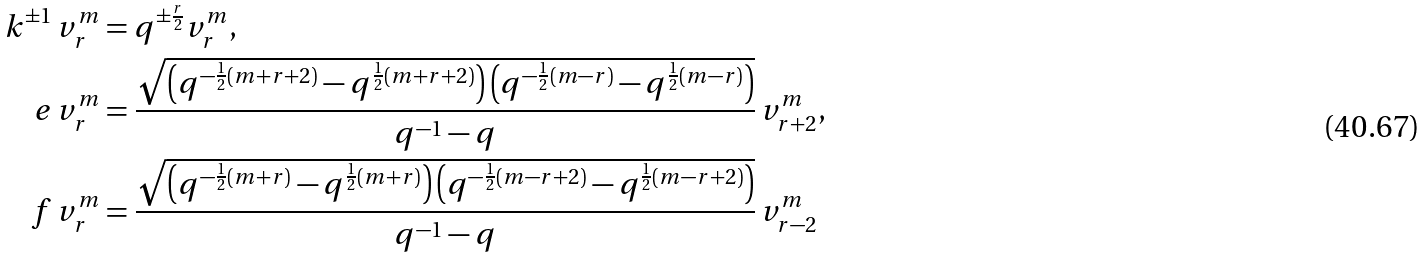Convert formula to latex. <formula><loc_0><loc_0><loc_500><loc_500>k ^ { \pm 1 } \, v _ { r } ^ { m } & = q ^ { \pm \frac { r } { 2 } } v _ { r } ^ { m } , \\ e \, v _ { r } ^ { m } & = \frac { \sqrt { \left ( q ^ { - \frac { 1 } { 2 } ( m + r + 2 ) } - q ^ { \frac { 1 } { 2 } ( m + r + 2 ) } \right ) \left ( q ^ { - \frac { 1 } { 2 } ( m - r ) } - q ^ { \frac { 1 } { 2 } ( m - r ) } \right ) } } { q ^ { - 1 } - q } \, v _ { r + 2 } ^ { m } , \\ f \, v _ { r } ^ { m } & = \frac { \sqrt { \left ( q ^ { - \frac { 1 } { 2 } ( m + r ) } - q ^ { \frac { 1 } { 2 } ( m + r ) } \right ) \left ( q ^ { - \frac { 1 } { 2 } ( m - r + 2 ) } - q ^ { \frac { 1 } { 2 } ( m - r + 2 ) } \right ) } } { q ^ { - 1 } - q } \, v _ { r - 2 } ^ { m }</formula> 